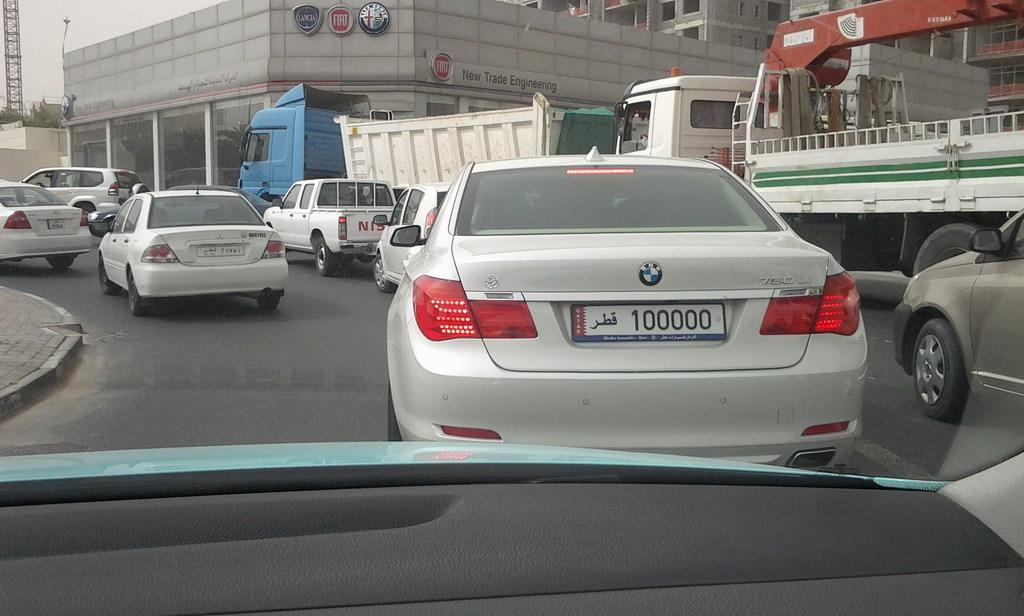What types of vehicles can be seen on the road in the image? There are cars and trucks on the road in the image. What is the structure visible in the image? There is a building with windows visible in the image. What is visible in the background of the image? The sky is visible in the image. Where is the lunchroom located in the image? There is no lunchroom present in the image. How many dogs can be seen in the image? There are no dogs visible in the image. 